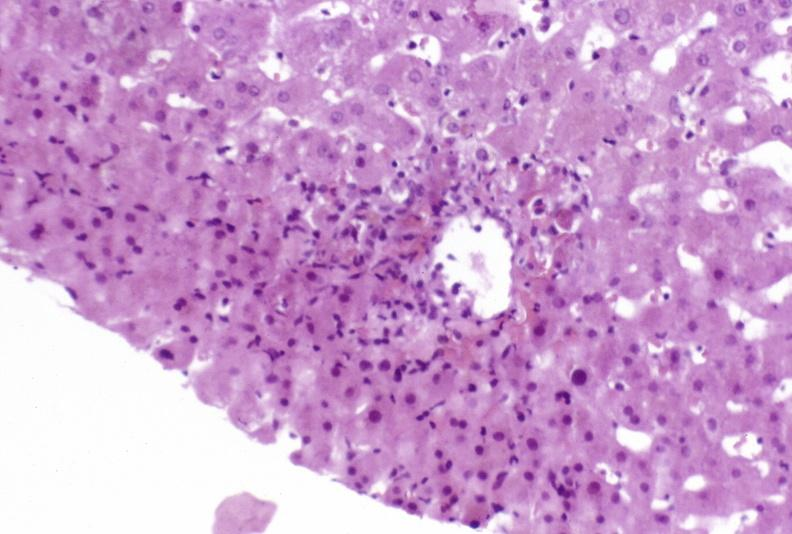does this image show moderate acute rejection?
Answer the question using a single word or phrase. Yes 